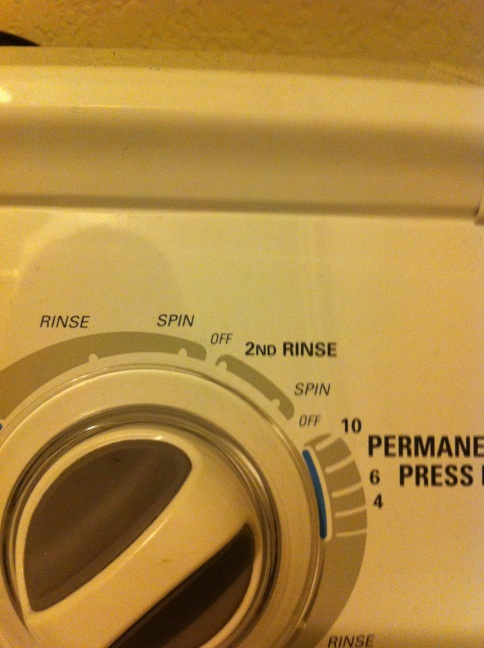Imagine if the washer dial had magical properties. What kind of mythical cycles could it offer? Imagine the washer dial had magical properties! It might offer cycles like 'Stain Vanisher,' which could eliminate any stain with a single wash, despite how stubborn it might be. Another cycle could be 'Fabric Rejuvenator,' capable of making old, worn-out clothes look brand new. There could also be the 'Color Enhancer' cycle, which would not only wash but also refresh and brighten the colors of your clothes as if they were new again. The mythical 'Shrinking Saver' cycle might undo accidental shrinking, restoring clothes to their original size. The possibilities would be endless and clothes would always come out looking immaculate! 